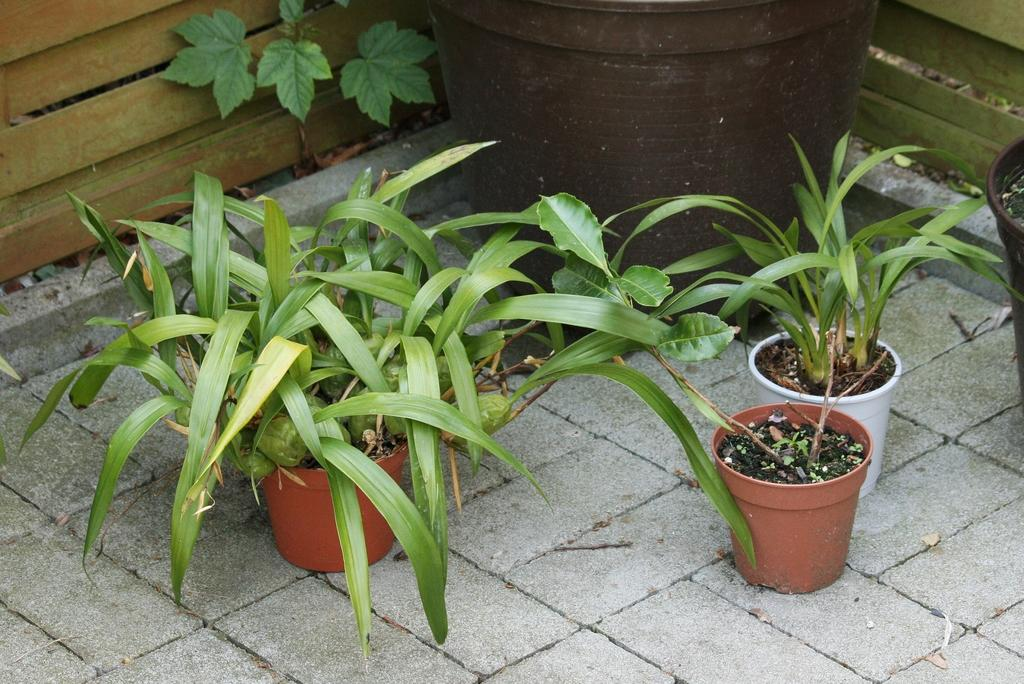What objects are visible in the image that contain plants? There are plant pots in the image that contain plants. Can you describe the type of plants in the pots? The provided facts do not specify the type of plants in the pots. What is visible in the background of the image? There is a wooden fence in the background of the image. How many chickens can be seen interacting with the plant pots in the image? There are no chickens present in the image; it only features plant pots and a wooden fence in the background. 